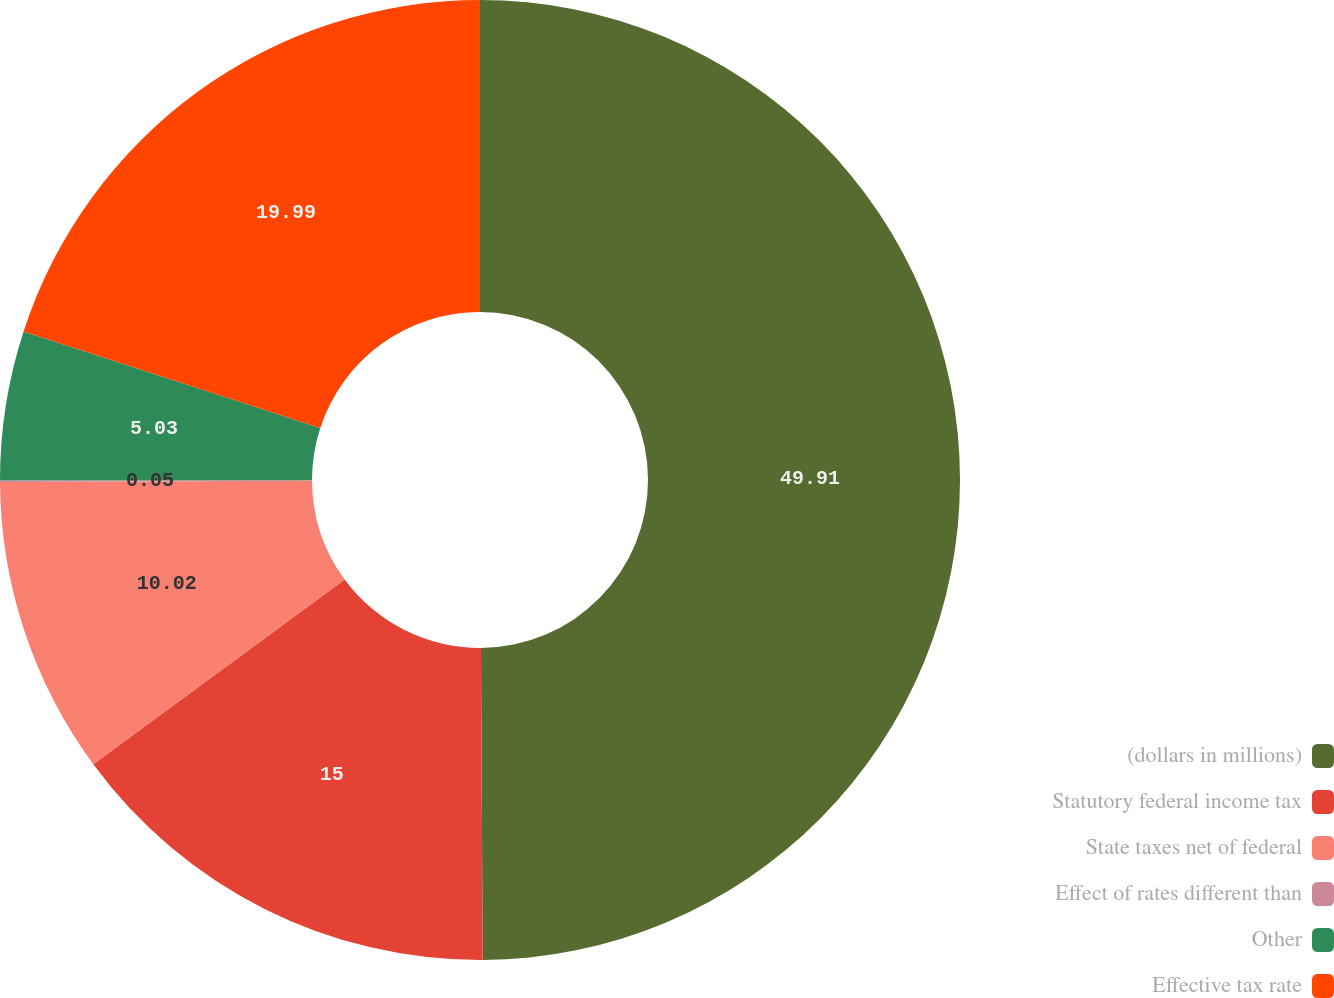<chart> <loc_0><loc_0><loc_500><loc_500><pie_chart><fcel>(dollars in millions)<fcel>Statutory federal income tax<fcel>State taxes net of federal<fcel>Effect of rates different than<fcel>Other<fcel>Effective tax rate<nl><fcel>49.91%<fcel>15.0%<fcel>10.02%<fcel>0.05%<fcel>5.03%<fcel>19.99%<nl></chart> 